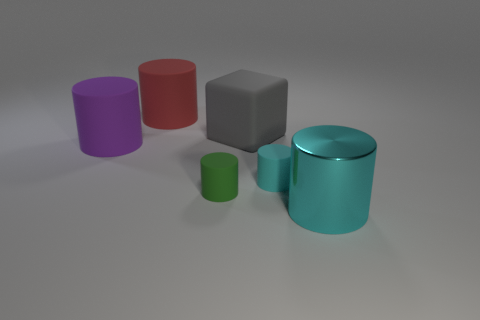Is there any other thing that is the same shape as the big gray object?
Provide a short and direct response. No. What is the shape of the large red thing that is made of the same material as the tiny cyan object?
Ensure brevity in your answer.  Cylinder. What size is the cyan cylinder behind the object that is to the right of the cyan thing behind the big metallic thing?
Ensure brevity in your answer.  Small. Are there more green rubber cylinders than large yellow things?
Provide a succinct answer. Yes. Do the rubber cylinder to the right of the large matte block and the matte object that is to the left of the red matte cylinder have the same color?
Your answer should be compact. No. Does the cyan thing that is on the left side of the big cyan thing have the same material as the big cylinder in front of the big purple rubber cylinder?
Offer a very short reply. No. How many gray things are the same size as the rubber cube?
Make the answer very short. 0. Is the number of tiny cyan cylinders less than the number of tiny cylinders?
Your answer should be compact. Yes. There is a large rubber object right of the matte thing in front of the tiny cyan cylinder; what shape is it?
Offer a terse response. Cube. What is the shape of the object that is the same size as the cyan matte cylinder?
Offer a terse response. Cylinder. 